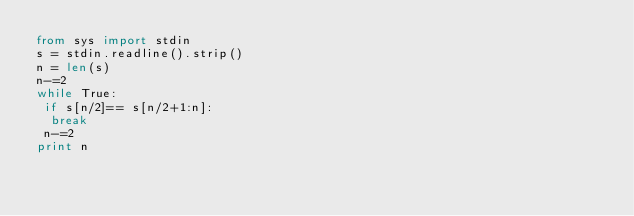Convert code to text. <code><loc_0><loc_0><loc_500><loc_500><_Python_>from sys import stdin
s = stdin.readline().strip()
n = len(s)
n-=2
while True:
 if s[n/2]== s[n/2+1:n]:
  break
 n-=2
print n</code> 